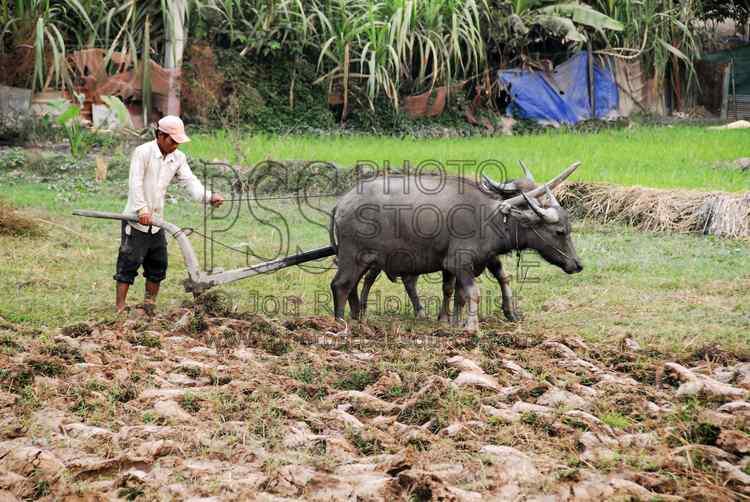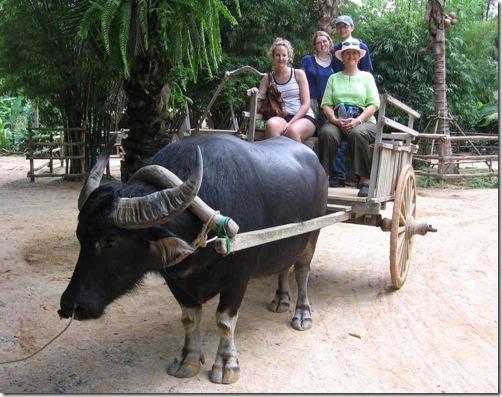The first image is the image on the left, the second image is the image on the right. Evaluate the accuracy of this statement regarding the images: "One image shows an ox pulling a cart with a thatched roof over passengers, and the other image shows at least one dark ox pulling a cart without a roof.". Is it true? Answer yes or no. No. 